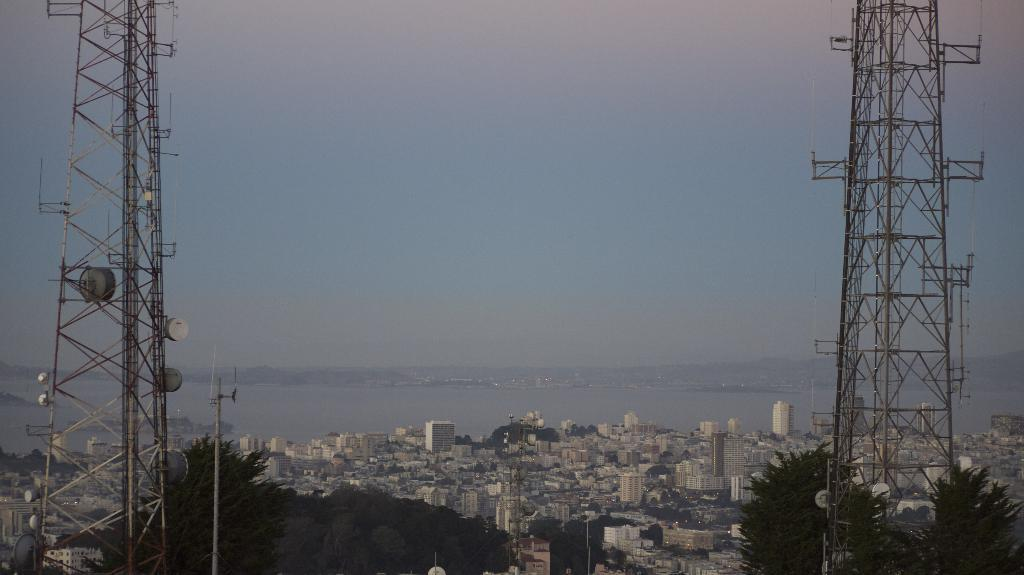How many towers are present in the image? There are two towers in the image. What is located at the bottom of the image? There are many buildings and trees at the bottom of the image. What can be seen in the background of the image? There is water visible in the background of the image. What is visible at the top of the image? The sky is visible at the top of the image. What type of belief is being expressed by the ocean in the image? There is no ocean present in the image, and therefore no belief can be attributed to it. 